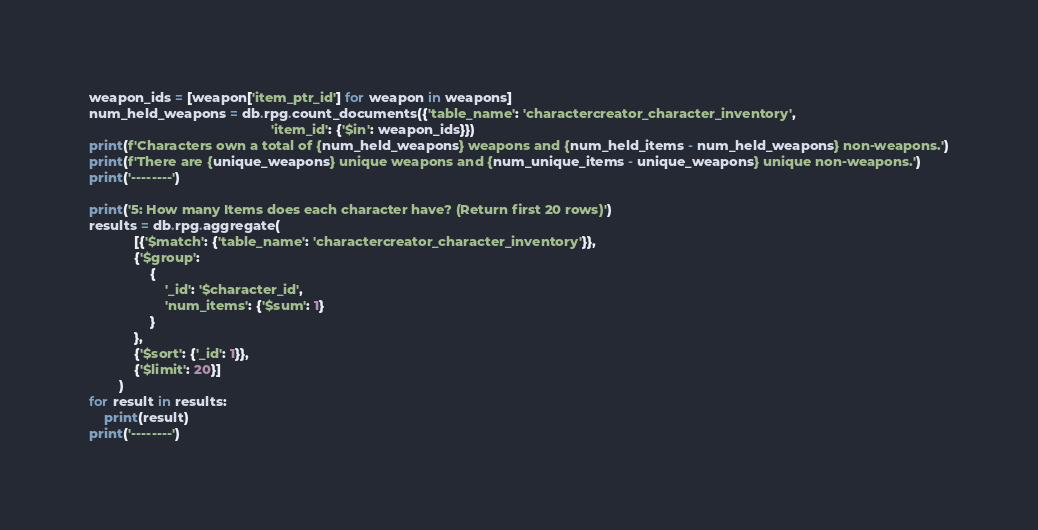Convert code to text. <code><loc_0><loc_0><loc_500><loc_500><_Python_>weapon_ids = [weapon['item_ptr_id'] for weapon in weapons]
num_held_weapons = db.rpg.count_documents({'table_name': 'charactercreator_character_inventory',
                                                'item_id': {'$in': weapon_ids}})
print(f'Characters own a total of {num_held_weapons} weapons and {num_held_items - num_held_weapons} non-weapons.')
print(f'There are {unique_weapons} unique weapons and {num_unique_items - unique_weapons} unique non-weapons.')
print('--------')

print('5: How many Items does each character have? (Return first 20 rows)')
results = db.rpg.aggregate(
            [{'$match': {'table_name': 'charactercreator_character_inventory'}},
            {'$group':
                {
                    '_id': '$character_id',
                    'num_items': {'$sum': 1}
                }
            },
            {'$sort': {'_id': 1}},
            {'$limit': 20}]
        )
for result in results:
    print(result)
print('--------')</code> 